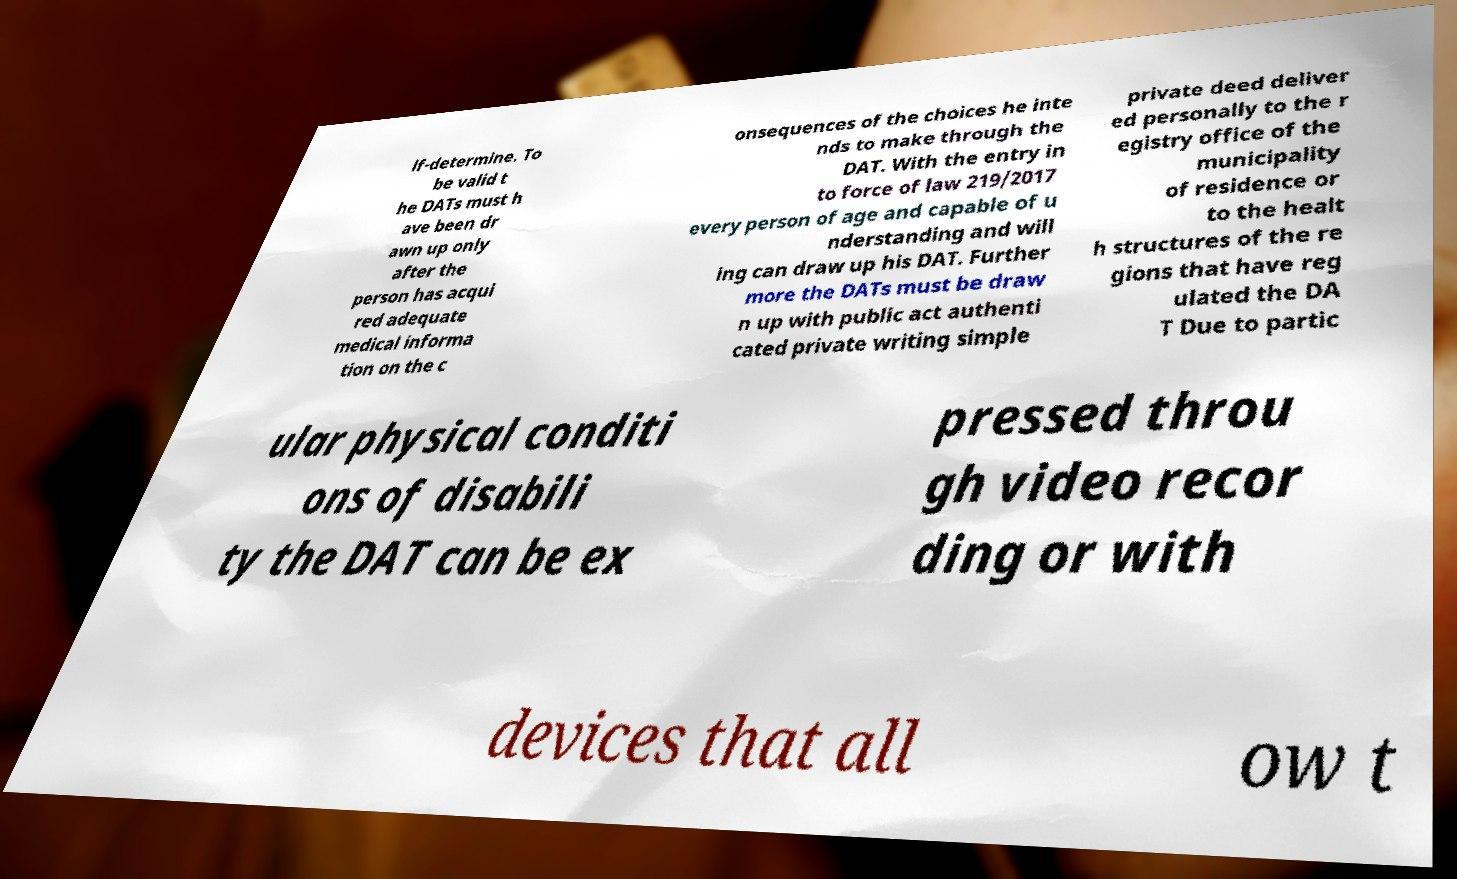Please read and relay the text visible in this image. What does it say? lf-determine. To be valid t he DATs must h ave been dr awn up only after the person has acqui red adequate medical informa tion on the c onsequences of the choices he inte nds to make through the DAT. With the entry in to force of law 219/2017 every person of age and capable of u nderstanding and will ing can draw up his DAT. Further more the DATs must be draw n up with public act authenti cated private writing simple private deed deliver ed personally to the r egistry office of the municipality of residence or to the healt h structures of the re gions that have reg ulated the DA T Due to partic ular physical conditi ons of disabili ty the DAT can be ex pressed throu gh video recor ding or with devices that all ow t 